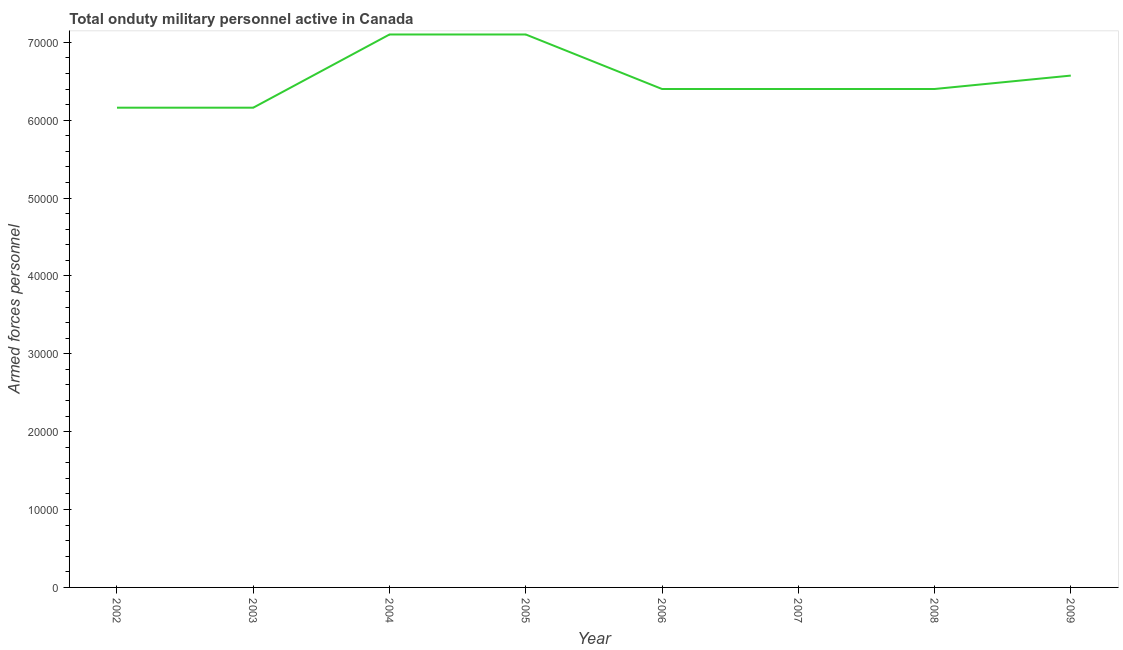What is the number of armed forces personnel in 2004?
Keep it short and to the point. 7.10e+04. Across all years, what is the maximum number of armed forces personnel?
Offer a very short reply. 7.10e+04. Across all years, what is the minimum number of armed forces personnel?
Keep it short and to the point. 6.16e+04. In which year was the number of armed forces personnel maximum?
Keep it short and to the point. 2004. In which year was the number of armed forces personnel minimum?
Offer a terse response. 2002. What is the sum of the number of armed forces personnel?
Your answer should be compact. 5.23e+05. What is the difference between the number of armed forces personnel in 2003 and 2009?
Provide a succinct answer. -4122. What is the average number of armed forces personnel per year?
Ensure brevity in your answer.  6.54e+04. What is the median number of armed forces personnel?
Your answer should be compact. 6.40e+04. Do a majority of the years between 2003 and 2002 (inclusive) have number of armed forces personnel greater than 20000 ?
Ensure brevity in your answer.  No. What is the ratio of the number of armed forces personnel in 2004 to that in 2009?
Make the answer very short. 1.08. Is the difference between the number of armed forces personnel in 2004 and 2006 greater than the difference between any two years?
Keep it short and to the point. No. What is the difference between the highest and the second highest number of armed forces personnel?
Offer a very short reply. 0. Is the sum of the number of armed forces personnel in 2002 and 2004 greater than the maximum number of armed forces personnel across all years?
Give a very brief answer. Yes. What is the difference between the highest and the lowest number of armed forces personnel?
Provide a short and direct response. 9400. Does the number of armed forces personnel monotonically increase over the years?
Ensure brevity in your answer.  No. How many lines are there?
Offer a very short reply. 1. How many years are there in the graph?
Give a very brief answer. 8. What is the difference between two consecutive major ticks on the Y-axis?
Provide a short and direct response. 10000. Does the graph contain any zero values?
Ensure brevity in your answer.  No. What is the title of the graph?
Make the answer very short. Total onduty military personnel active in Canada. What is the label or title of the X-axis?
Keep it short and to the point. Year. What is the label or title of the Y-axis?
Ensure brevity in your answer.  Armed forces personnel. What is the Armed forces personnel of 2002?
Offer a terse response. 6.16e+04. What is the Armed forces personnel of 2003?
Provide a succinct answer. 6.16e+04. What is the Armed forces personnel in 2004?
Offer a terse response. 7.10e+04. What is the Armed forces personnel of 2005?
Your answer should be very brief. 7.10e+04. What is the Armed forces personnel of 2006?
Your answer should be compact. 6.40e+04. What is the Armed forces personnel of 2007?
Make the answer very short. 6.40e+04. What is the Armed forces personnel of 2008?
Give a very brief answer. 6.40e+04. What is the Armed forces personnel in 2009?
Make the answer very short. 6.57e+04. What is the difference between the Armed forces personnel in 2002 and 2003?
Keep it short and to the point. 0. What is the difference between the Armed forces personnel in 2002 and 2004?
Offer a very short reply. -9400. What is the difference between the Armed forces personnel in 2002 and 2005?
Give a very brief answer. -9400. What is the difference between the Armed forces personnel in 2002 and 2006?
Provide a succinct answer. -2400. What is the difference between the Armed forces personnel in 2002 and 2007?
Give a very brief answer. -2400. What is the difference between the Armed forces personnel in 2002 and 2008?
Offer a terse response. -2400. What is the difference between the Armed forces personnel in 2002 and 2009?
Make the answer very short. -4122. What is the difference between the Armed forces personnel in 2003 and 2004?
Ensure brevity in your answer.  -9400. What is the difference between the Armed forces personnel in 2003 and 2005?
Give a very brief answer. -9400. What is the difference between the Armed forces personnel in 2003 and 2006?
Provide a short and direct response. -2400. What is the difference between the Armed forces personnel in 2003 and 2007?
Keep it short and to the point. -2400. What is the difference between the Armed forces personnel in 2003 and 2008?
Keep it short and to the point. -2400. What is the difference between the Armed forces personnel in 2003 and 2009?
Offer a terse response. -4122. What is the difference between the Armed forces personnel in 2004 and 2005?
Keep it short and to the point. 0. What is the difference between the Armed forces personnel in 2004 and 2006?
Offer a terse response. 7000. What is the difference between the Armed forces personnel in 2004 and 2007?
Your answer should be very brief. 7000. What is the difference between the Armed forces personnel in 2004 and 2008?
Provide a short and direct response. 7000. What is the difference between the Armed forces personnel in 2004 and 2009?
Offer a terse response. 5278. What is the difference between the Armed forces personnel in 2005 and 2006?
Offer a very short reply. 7000. What is the difference between the Armed forces personnel in 2005 and 2007?
Ensure brevity in your answer.  7000. What is the difference between the Armed forces personnel in 2005 and 2008?
Keep it short and to the point. 7000. What is the difference between the Armed forces personnel in 2005 and 2009?
Provide a succinct answer. 5278. What is the difference between the Armed forces personnel in 2006 and 2007?
Make the answer very short. 0. What is the difference between the Armed forces personnel in 2006 and 2009?
Offer a terse response. -1722. What is the difference between the Armed forces personnel in 2007 and 2008?
Your response must be concise. 0. What is the difference between the Armed forces personnel in 2007 and 2009?
Give a very brief answer. -1722. What is the difference between the Armed forces personnel in 2008 and 2009?
Keep it short and to the point. -1722. What is the ratio of the Armed forces personnel in 2002 to that in 2004?
Your response must be concise. 0.87. What is the ratio of the Armed forces personnel in 2002 to that in 2005?
Your answer should be compact. 0.87. What is the ratio of the Armed forces personnel in 2002 to that in 2007?
Provide a succinct answer. 0.96. What is the ratio of the Armed forces personnel in 2002 to that in 2008?
Offer a terse response. 0.96. What is the ratio of the Armed forces personnel in 2002 to that in 2009?
Provide a succinct answer. 0.94. What is the ratio of the Armed forces personnel in 2003 to that in 2004?
Provide a short and direct response. 0.87. What is the ratio of the Armed forces personnel in 2003 to that in 2005?
Ensure brevity in your answer.  0.87. What is the ratio of the Armed forces personnel in 2003 to that in 2007?
Give a very brief answer. 0.96. What is the ratio of the Armed forces personnel in 2003 to that in 2008?
Offer a very short reply. 0.96. What is the ratio of the Armed forces personnel in 2003 to that in 2009?
Your answer should be very brief. 0.94. What is the ratio of the Armed forces personnel in 2004 to that in 2005?
Provide a short and direct response. 1. What is the ratio of the Armed forces personnel in 2004 to that in 2006?
Your response must be concise. 1.11. What is the ratio of the Armed forces personnel in 2004 to that in 2007?
Offer a very short reply. 1.11. What is the ratio of the Armed forces personnel in 2004 to that in 2008?
Provide a short and direct response. 1.11. What is the ratio of the Armed forces personnel in 2004 to that in 2009?
Your response must be concise. 1.08. What is the ratio of the Armed forces personnel in 2005 to that in 2006?
Your answer should be compact. 1.11. What is the ratio of the Armed forces personnel in 2005 to that in 2007?
Give a very brief answer. 1.11. What is the ratio of the Armed forces personnel in 2005 to that in 2008?
Your response must be concise. 1.11. What is the ratio of the Armed forces personnel in 2005 to that in 2009?
Keep it short and to the point. 1.08. What is the ratio of the Armed forces personnel in 2006 to that in 2007?
Keep it short and to the point. 1. What is the ratio of the Armed forces personnel in 2006 to that in 2009?
Offer a very short reply. 0.97. What is the ratio of the Armed forces personnel in 2007 to that in 2008?
Make the answer very short. 1. 